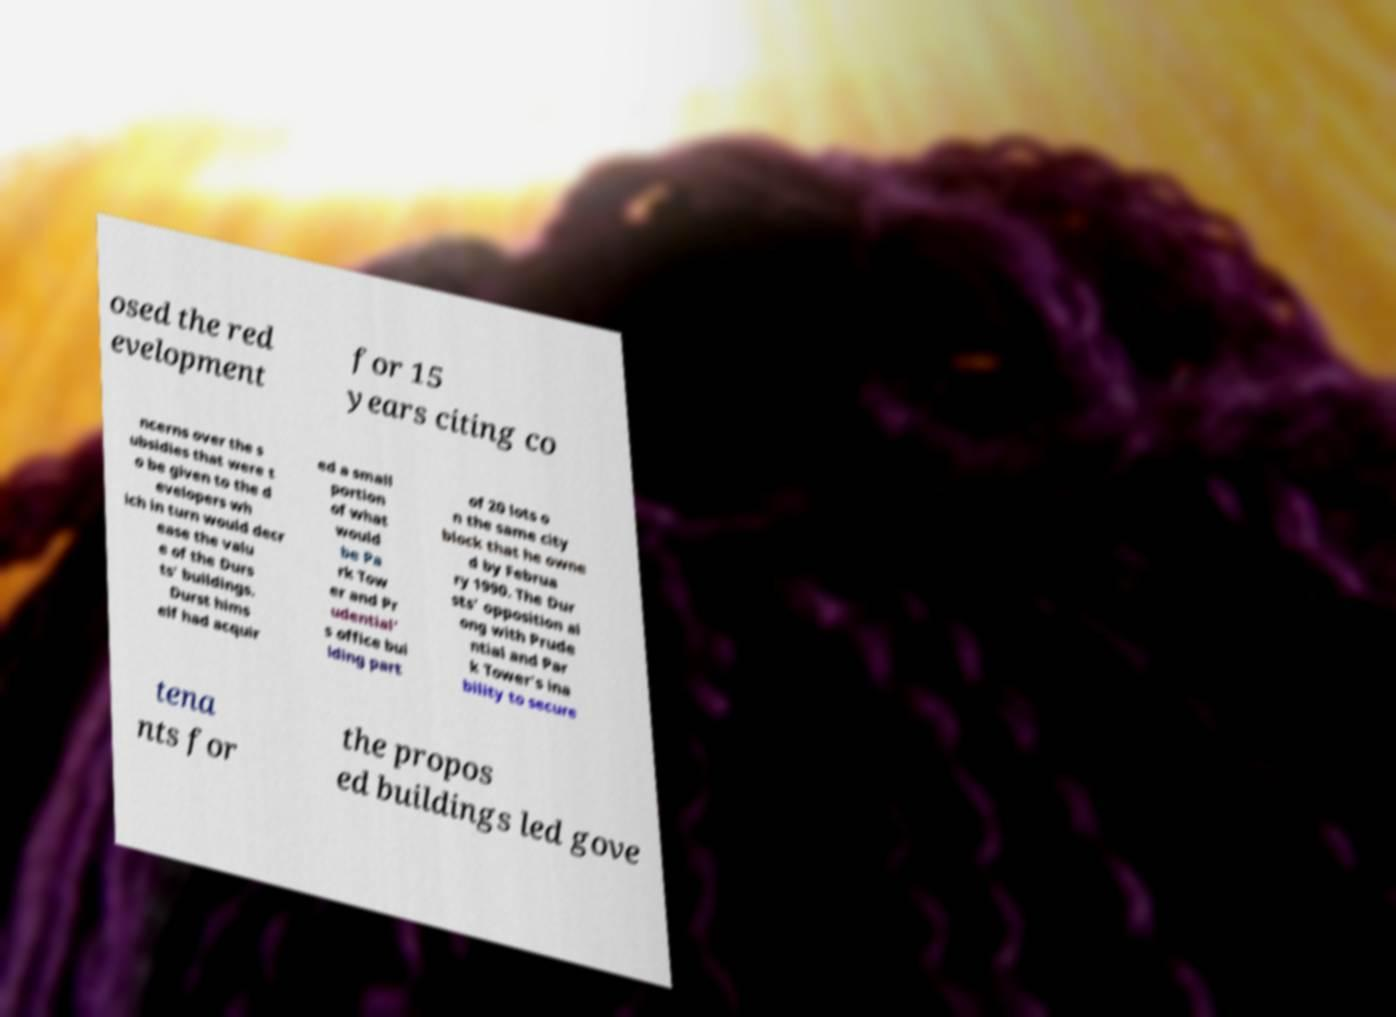Please read and relay the text visible in this image. What does it say? osed the red evelopment for 15 years citing co ncerns over the s ubsidies that were t o be given to the d evelopers wh ich in turn would decr ease the valu e of the Durs ts' buildings. Durst hims elf had acquir ed a small portion of what would be Pa rk Tow er and Pr udential' s office bui lding part of 20 lots o n the same city block that he owne d by Februa ry 1990. The Dur sts' opposition al ong with Prude ntial and Par k Tower's ina bility to secure tena nts for the propos ed buildings led gove 